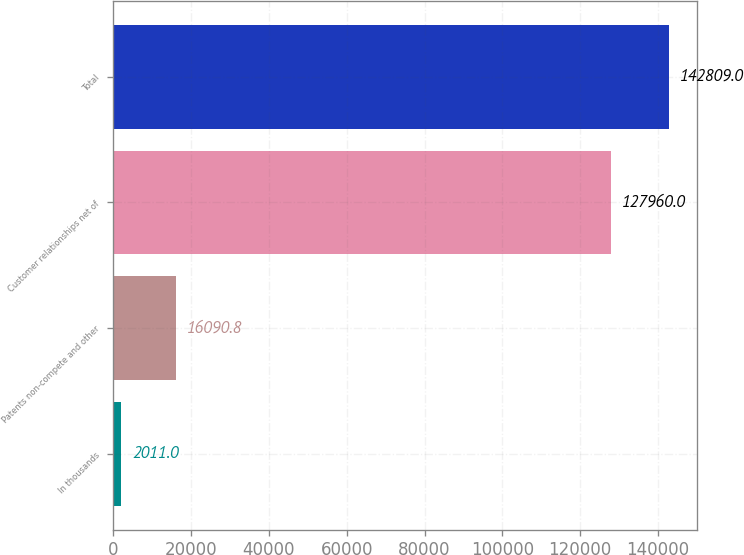Convert chart. <chart><loc_0><loc_0><loc_500><loc_500><bar_chart><fcel>In thousands<fcel>Patents non-compete and other<fcel>Customer relationships net of<fcel>Total<nl><fcel>2011<fcel>16090.8<fcel>127960<fcel>142809<nl></chart> 